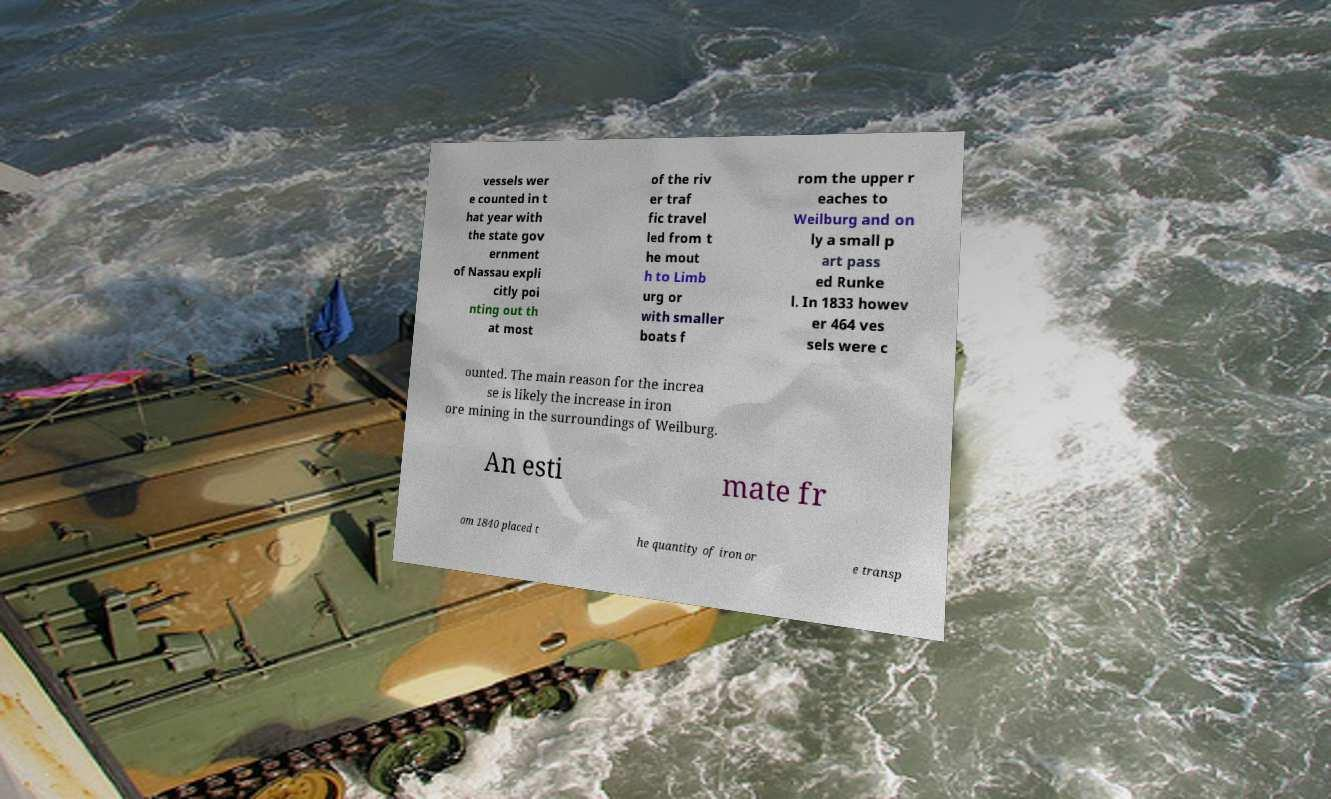Can you read and provide the text displayed in the image?This photo seems to have some interesting text. Can you extract and type it out for me? vessels wer e counted in t hat year with the state gov ernment of Nassau expli citly poi nting out th at most of the riv er traf fic travel led from t he mout h to Limb urg or with smaller boats f rom the upper r eaches to Weilburg and on ly a small p art pass ed Runke l. In 1833 howev er 464 ves sels were c ounted. The main reason for the increa se is likely the increase in iron ore mining in the surroundings of Weilburg. An esti mate fr om 1840 placed t he quantity of iron or e transp 